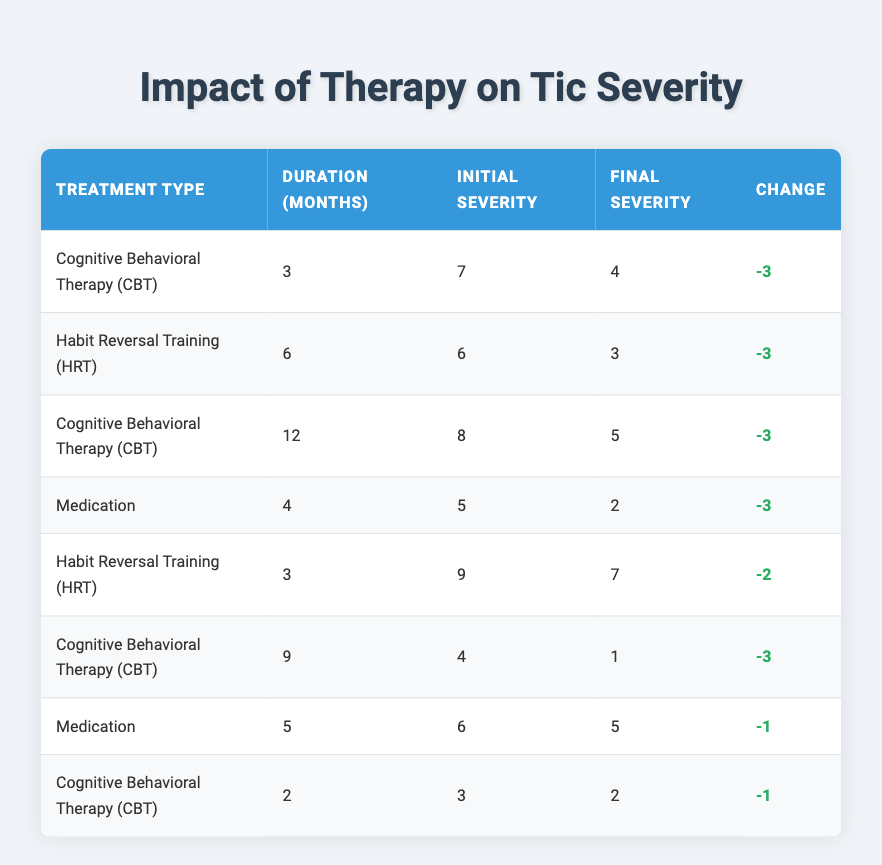What is the initial tic severity for the patient receiving Habit Reversal Training for 6 months? The table shows that the patient receiving Habit Reversal Training for 6 months has an initial tic severity of 6.
Answer: 6 What was the final tic severity for the Cognitive Behavioral Therapy group after 9 months? The table indicates that for the Cognitive Behavioral Therapy group after 9 months, the final tic severity is 1.
Answer: 1 Which treatment had the highest initial tic severity, and what was that severity? By examining the initial severity values in the table, the Habit Reversal Training group had the highest initial severity of 9.
Answer: 9 How many patients had a final tic severity that was unchanged or worsened? Reviewing the final severity, only the patient under Medication for 5 months had an unchanged severity (5), so there is 1 patient in total with no improvement.
Answer: 1 What is the average change in tic severity for patients treated with Cognitive Behavioral Therapy? To calculate the average change for CBT: You find the changes as follows: -3 (3 mos), -3 (12 mos), -3 (9 mos), -1 (2 mos) totaling -10 across 4 patients. The average change is -10 divided by 4, which equals -2.5.
Answer: -2.5 Did the patients who received Medication show an overall improvement? The table indicates that there were 2 patients treated with Medication, one with improved severity (from 5 to 2) and one that remained unchanged (from 6 to 5). Since one improved, the answer is yes.
Answer: Yes Which treatment type had the lowest average final tic severity? By calculating the final severities for each treatment type: CBT (1.75), HRT (5), and Medication (3.5), CBT shows the lowest average final severity of 1.75.
Answer: CBT What percentage of patients experienced improved tic severity after therapy? Of the 8 total patients listed, 6 had improved severity. The percentage is calculated by (6/8) * 100 = 75%.
Answer: 75% 